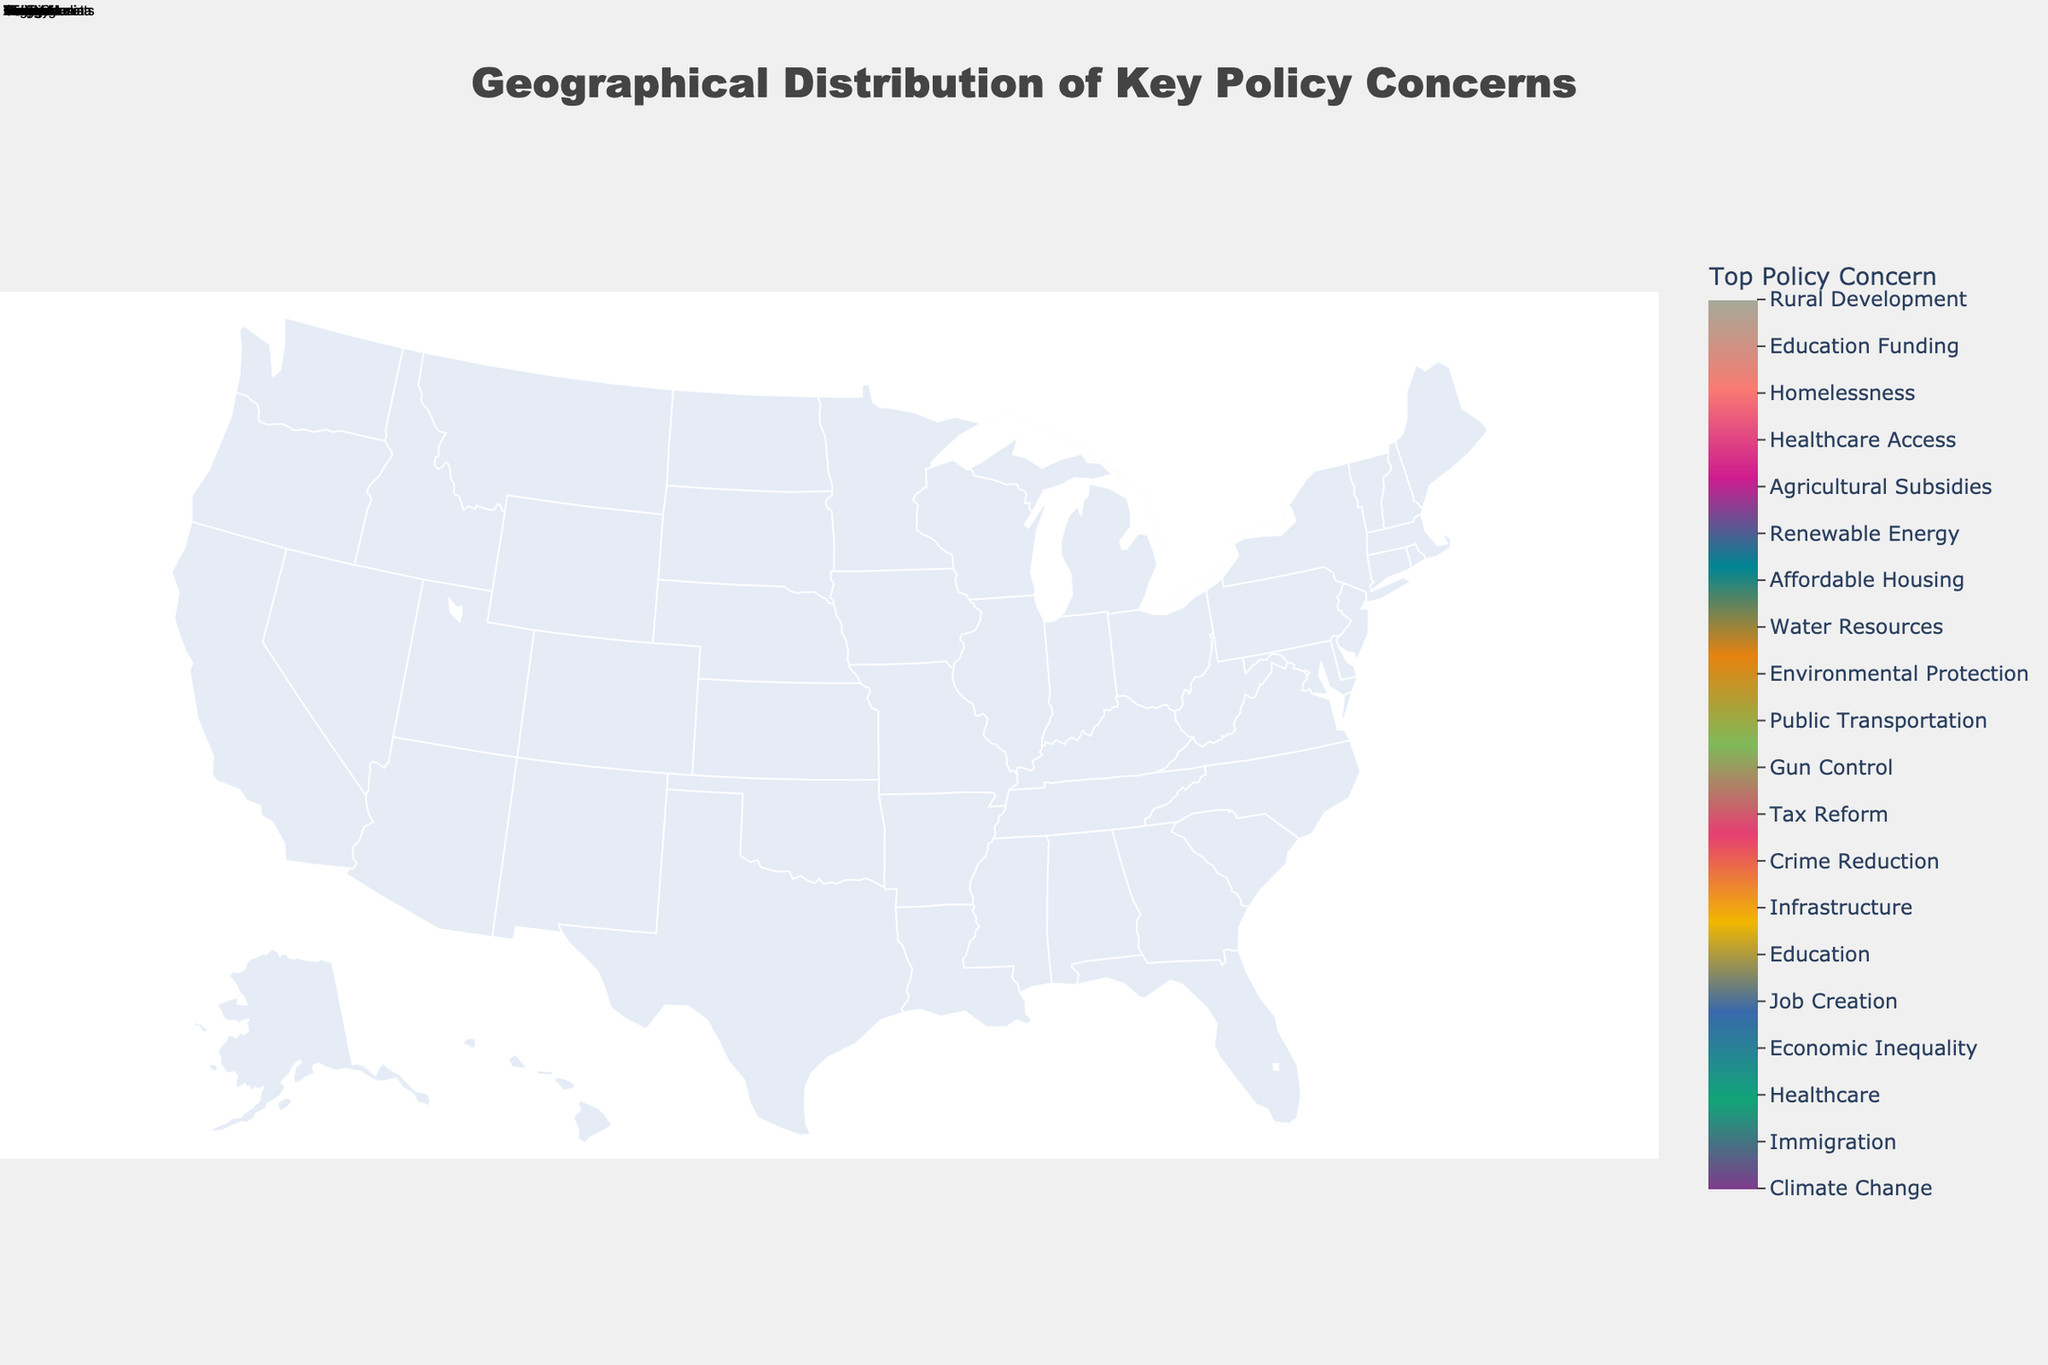What is the top policy concern in California? The figure shows the top policy concerns for each state. For California, the color coding and the text make it clear that Climate Change is the top policy concern.
Answer: Climate Change Which state has Healthcare as its top policy concern? To find this, look at the figure's legend and the state labeled with the corresponding color for Healthcare. Florida is labeled with the color and text for Healthcare.
Answer: Florida How many states have Education as their top policy concern? Looking at the legend and the states labeled with Education, two states (Pennsylvania and Maryland) have Education or Education Funding as their top concern.
Answer: Two What are the top policy concerns for New York and Texas? By referring to the labels and color coding on the figure, New York's top policy concern is Economic Inequality, and Texas's top policy concern is Immigration.
Answer: Economic Inequality and Immigration Which state’s top policy concern is Affordable Housing, and how does it compare to the neighboring states' concerns? Massachusetts has the top policy concern of Affordable Housing. Comparing it with the neighboring states: New York is focused on Economic Inequality, and Pennsylvania is focused on Education.
Answer: Massachusetts: Affordable Housing, New York: Economic Inequality, Pennsylvania: Education Is there any common policy concern shared by multiple states? By looking at the figure and the text labels, Education (Pennsylvania and Maryland) and Healthcare (Florida and Minnesota) are recurring concerns in multiple states.
Answer: Yes, Education and Healthcare What is the predominant policy concern in the Midwest region? By examining the top concerns across the Midwest states (e.g., Ohio, Illinois, Wisconsin, Michigan), the concerns vary: Job Creation (Ohio), Public Transportation (Illinois), Agricultural Subsidies (Wisconsin), and Infrastructure (Michigan). No single concern predominates.
Answer: No single predominant concern Compare the policy concerns of the states along the West Coast. The West Coast states include California, Oregon, and Washington. Their top policy concerns are Climate Change (California), Homelessness (Oregon), and Environmental Protection (Washington), showing a focus on environmental and social issues.
Answer: Climate Change, Homelessness, Environmental Protection What top policy concern in the Southern states involves crime or safety? Looking at the Southern states, Georgia has Crime Reduction as its top policy concern.
Answer: Crime Reduction (Georgia) Which states have environmental-related policy concerns as their top priority? The figure shows that the states with environmental-related policy concerns include California (Climate Change), Washington (Environmental Protection), and Colorado (Renewable Energy).
Answer: California, Washington, Colorado 